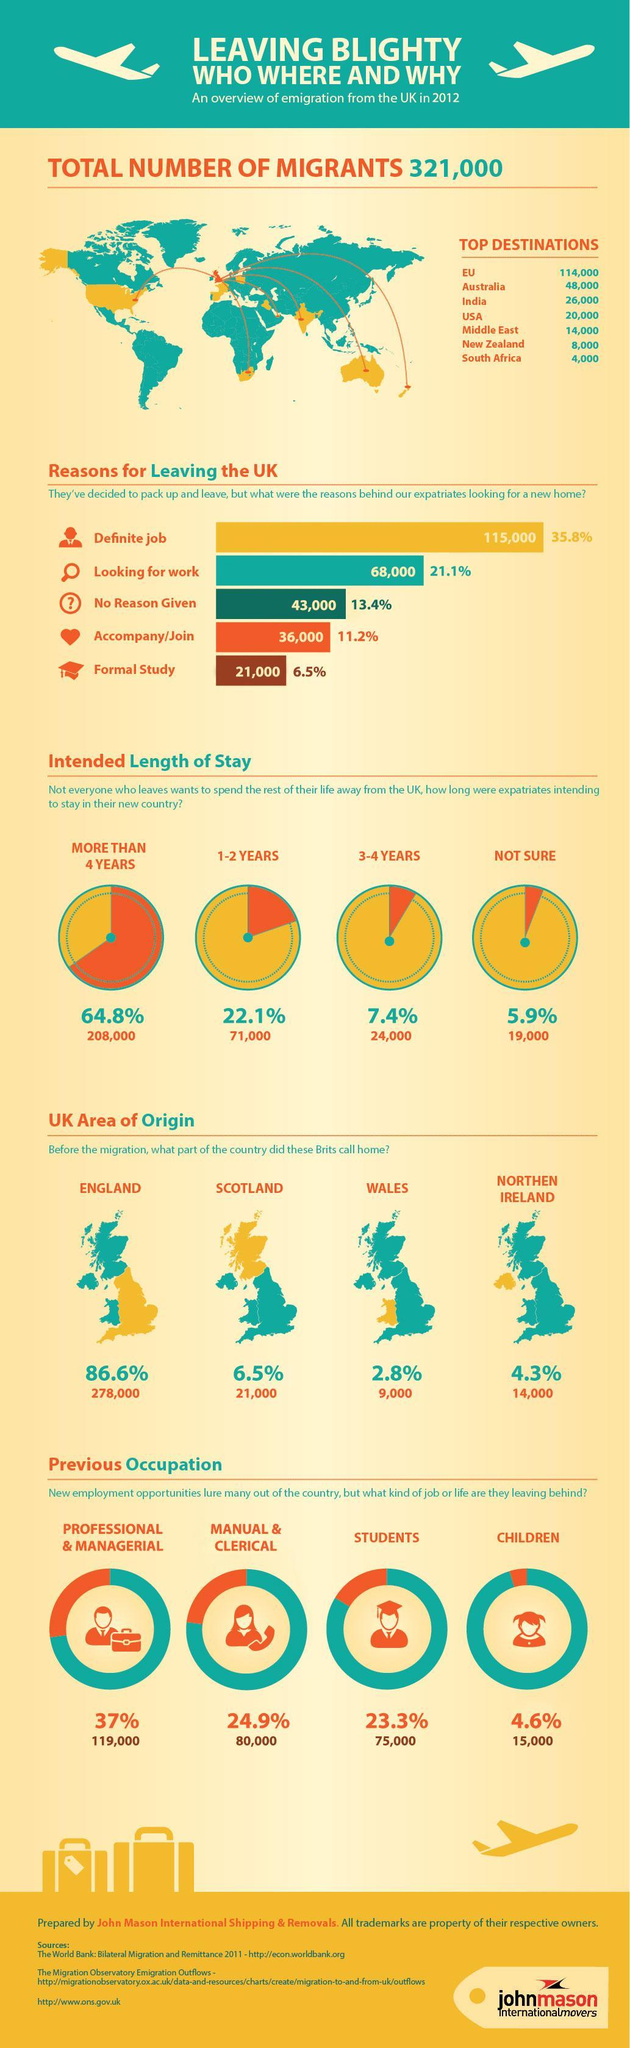Which was the sixth most popular destination for the migrants?
Answer the question with a short phrase. New Zealand For what reason did most of them leave UK for? Definite Job Where did the migrants mostly migrate to? EU How many migrants haled from Wales before they migrated? 9,000 Which part of the country did most of these expatriates call home before leaving? England Which was the third most popular destination for them? India How many migrants were students before they left? 75,000 What percent of the migrants haled from Northern Ireland? 4.3% What percent of expatriates left for a new place for formal studies? 6.5% How many expatriates were not sure about their length of stay in the new country? 19,000 How many migrants were children when they left? 15,000 What is the second most stated reason for expatriates to look for a new home? looking for work 